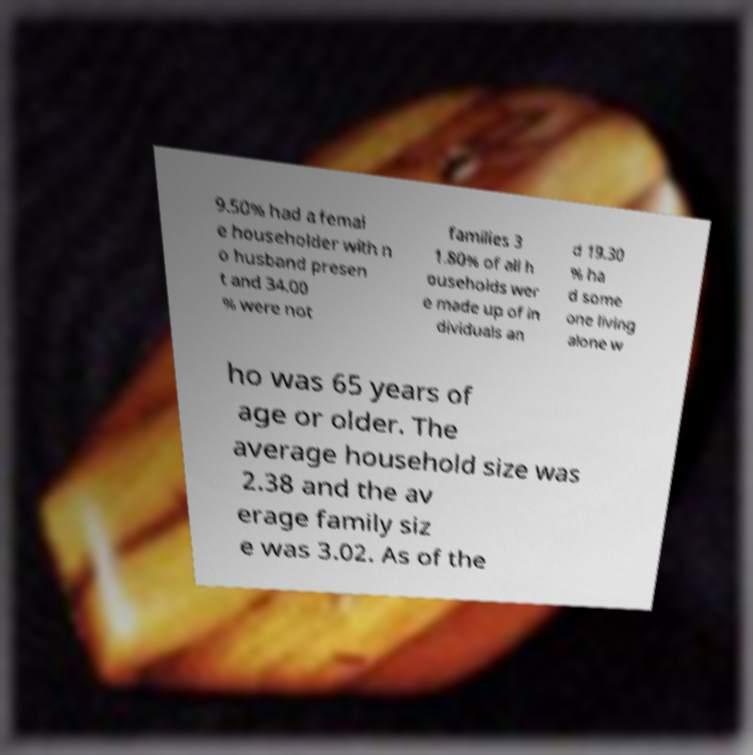Can you accurately transcribe the text from the provided image for me? 9.50% had a femal e householder with n o husband presen t and 34.00 % were not families 3 1.80% of all h ouseholds wer e made up of in dividuals an d 19.30 % ha d some one living alone w ho was 65 years of age or older. The average household size was 2.38 and the av erage family siz e was 3.02. As of the 